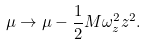<formula> <loc_0><loc_0><loc_500><loc_500>\mu \rightarrow \mu - \frac { 1 } { 2 } M \omega _ { z } ^ { 2 } z ^ { 2 } .</formula> 